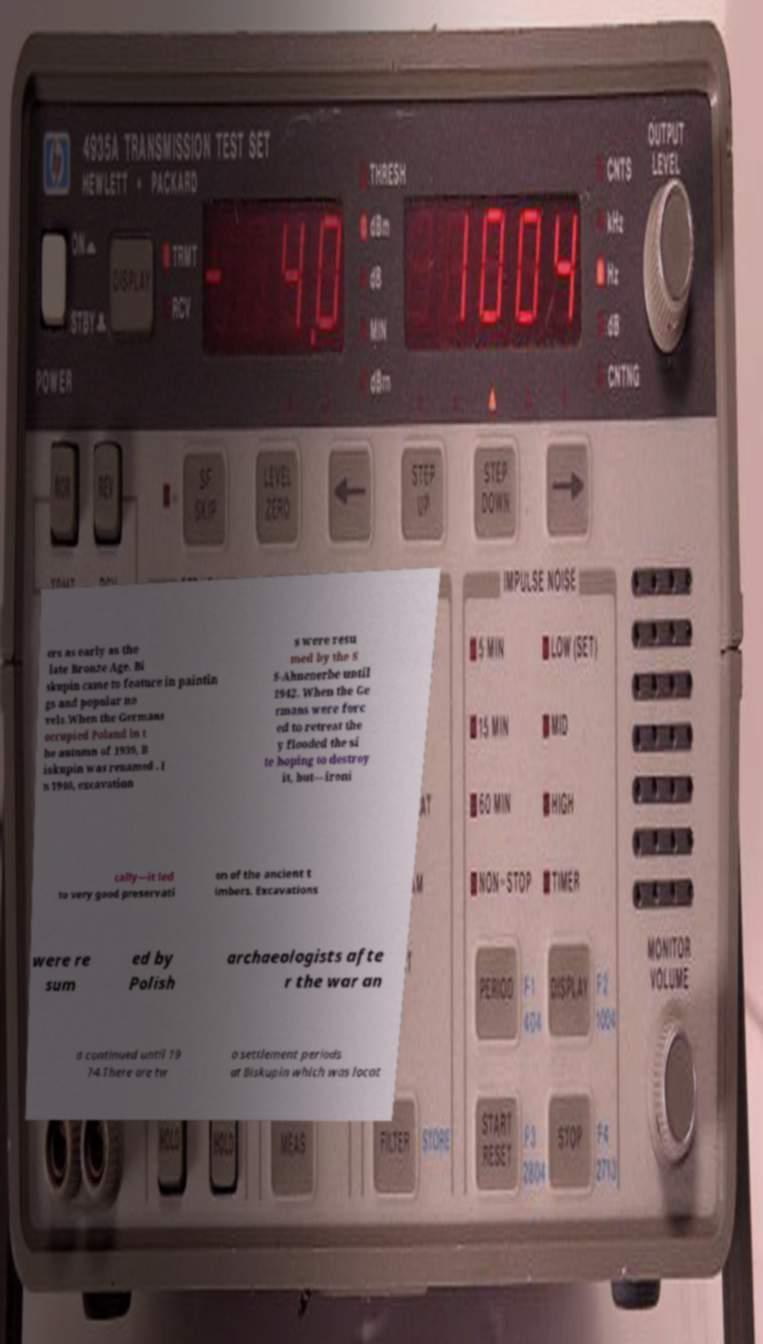Can you read and provide the text displayed in the image?This photo seems to have some interesting text. Can you extract and type it out for me? ers as early as the late Bronze Age. Bi skupin came to feature in paintin gs and popular no vels.When the Germans occupied Poland in t he autumn of 1939, B iskupin was renamed . I n 1940, excavation s were resu med by the S S-Ahnenerbe until 1942. When the Ge rmans were forc ed to retreat the y flooded the si te hoping to destroy it, but—ironi cally—it led to very good preservati on of the ancient t imbers. Excavations were re sum ed by Polish archaeologists afte r the war an d continued until 19 74.There are tw o settlement periods at Biskupin which was locat 